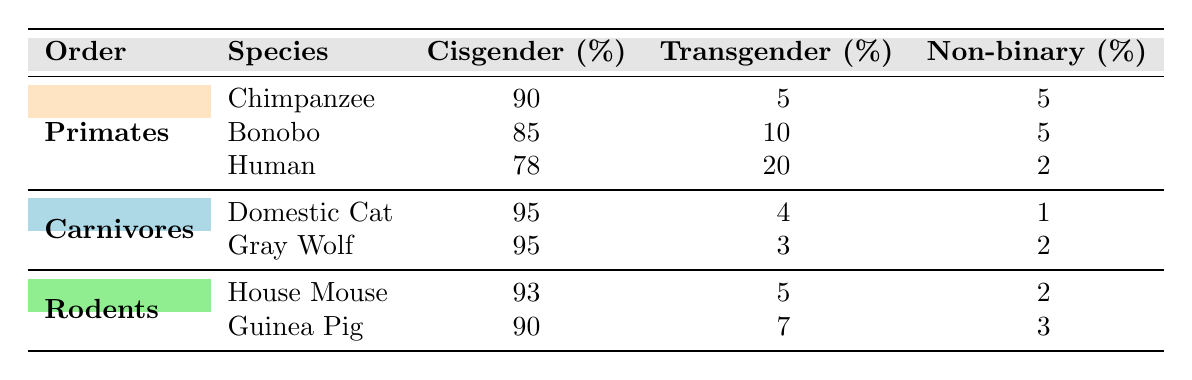What is the percentage of non-binary individuals in chimpanzees? According to the table, the percentage of non-binary individuals in chimpanzees is listed directly under the "Non-binary (%)" column for the "Chimpanzee" species. It shows 5%.
Answer: 5% Which species has the lowest percentage of cisgender individuals? The table lists the percentage of cisgender individuals for each species. The species with the lowest cisgender percentage is "Human," which has 78%.
Answer: Human What is the total percentage of transgender individuals across all primate species in the table? The transgender percentages for primates are added as follows: Chimpanzee (5) + Bonobo (10) + Human (20) = 35%.
Answer: 35% Is the gender variability percentage of domestic cats higher than that of gray wolves? The table displays the percentages of gender variability for both domestic cats and gray wolves. Domestic cats have a transgender percentage of 4% and gray wolves have 3%. Since 4% (domestic cats) is greater than 3% (gray wolves), the statement is true.
Answer: Yes What species average percentage of non-binary individuals across all mammals displayed in the table? The non-binary percentages must first be summed: Chimpanzee (5) + Bonobo (5) + Human (2) + Domestic Cat (1) + Gray Wolf (2) + House Mouse (2) + Guinea Pig (3). The total is 20%. There are 7 species, so the average is 20% / 7 = approximately 2.86%.
Answer: Approximately 2.86% 